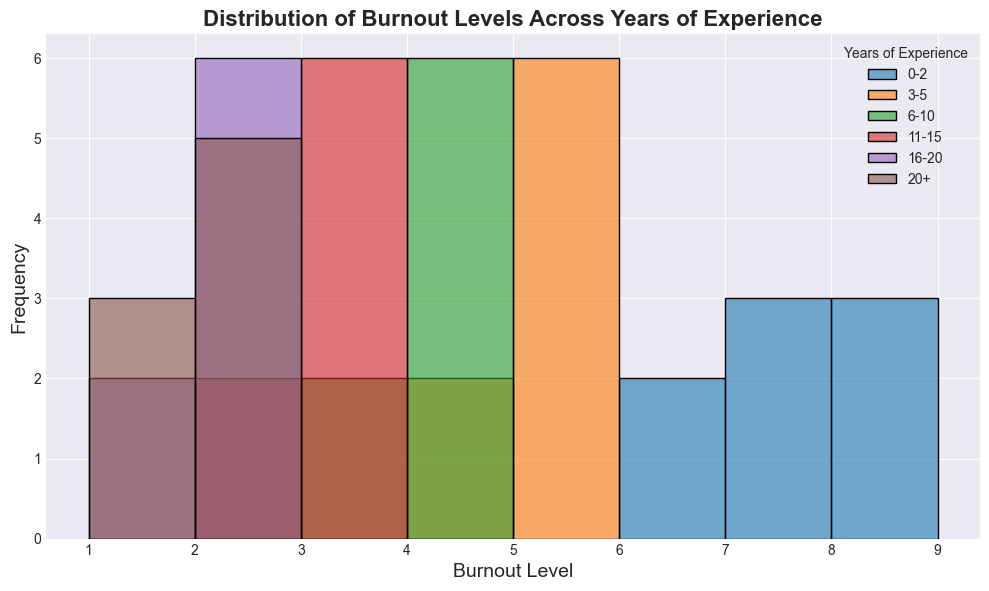What is the most frequent burnout level for healthcare professionals with 0-2 years of experience? Look at the bars in the histogram for the 0-2 years of experience section. The tallest bar represents the most frequent burnout level.
Answer: 7 Which group has the lowest median burnout level? To find the median burnout level, identify the middle value when data is ordered. Healthcare professionals with 16-20 years of experience have burnout levels ranging from 1 to 3, with 2 being the median. Other groups have higher median burnout levels.
Answer: 16-20 years of experience What is the difference in the range of burnout levels between the 0-2 years and the 20+ years experience groups? Calculate the range (max - min) for each group. For 0-2 years, the range is 9 - 6 = 3. For 20+ years, the range is 3 - 1 = 2. The difference in range is 3 - 2.
Answer: 1 Which group shows the most variety in burnout levels? Variety is indicated by the range of burnout levels (difference between highest and lowest levels). The 0-2 years group has the widest range (9 to 6). Comparatively, other groups have narrower ranges.
Answer: 0-2 years of experience Do healthcare professionals with more years of experience generally have lower burnout levels? Compare the general trends across groups. The histogram shows that groups with increasing years of experience have lower burnout levels. Specifically, burnout levels decrease as years of experience increase.
Answer: Yes How does the distribution of burnout levels for the 3-5 years group compare to the 6-10 years group? Look at the shapes and locations of the bars for both groups. The 3-5 years group has a peak around burnout levels 5-6, while the 6-10 years group shows a peak around 3-4 burnout levels. The distribution for 6-10 years is skewed lower.
Answer: The 6-10 years group has lower burnout levels compared to the 3-5 years group Are there any burnout levels that appear in all experience groups? Visualize the presence of burnout levels across different groups. Burnout level 2 appears in all segments from 11-15, 16-20, and 20+ years. However, burnout levels in the 0-2 years to 6-10 years groups do not show burnout level 2. No burnout levels are present in all groups.
Answer: No Which group has the most tightly clustered burnout levels around the mean? Identify the group with the narrowest spread around its average burnout level. The histogram indicates that the 20+ years group has burnout levels clustered around 1-2.
Answer: 20+ years of experience 